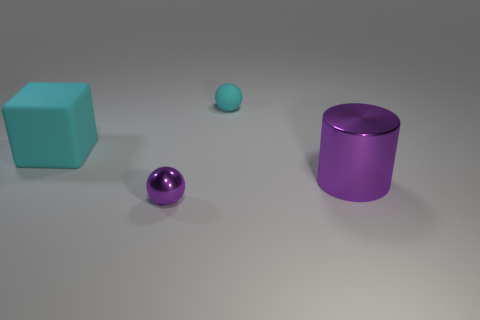Are there any tiny purple spheres to the left of the tiny cyan sphere?
Your answer should be very brief. Yes. Are there fewer matte balls in front of the small cyan rubber ball than large metallic cylinders?
Your answer should be very brief. Yes. What material is the large cyan thing?
Provide a short and direct response. Rubber. What color is the big metallic cylinder?
Give a very brief answer. Purple. The object that is in front of the big rubber object and behind the metal sphere is what color?
Your answer should be very brief. Purple. Is there any other thing that is the same material as the purple cylinder?
Your response must be concise. Yes. Do the cyan sphere and the tiny purple ball in front of the big cyan matte object have the same material?
Give a very brief answer. No. What size is the ball to the left of the rubber object right of the cyan matte cube?
Provide a short and direct response. Small. Are there any other things of the same color as the big cylinder?
Give a very brief answer. Yes. Are the purple thing that is on the left side of the big purple cylinder and the large thing that is left of the cylinder made of the same material?
Your answer should be very brief. No. 